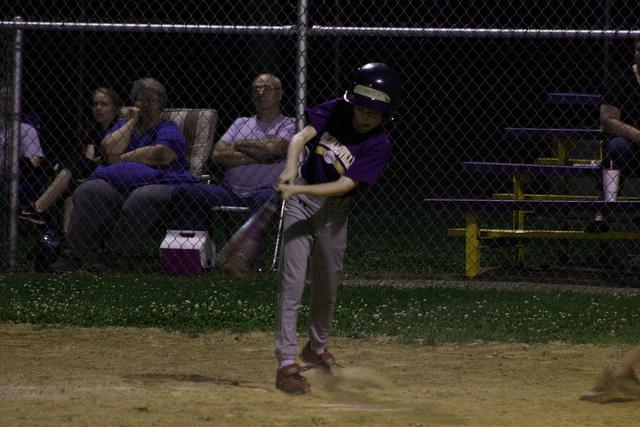How many people are on the playing field?
Quick response, please. 1. What is that sitting on the bleachers?
Short answer required. Cup. Is there a large audience?
Be succinct. No. How many bats do you see?
Short answer required. 1. Are the people behind the fence playing the game?
Be succinct. No. What is the guy doing?
Short answer required. Batting. What color are the uniforms?
Short answer required. Blue and gray. In what direction is the player reaching?
Quick response, please. Right. What sport is this?
Short answer required. Baseball. Is this part of an actual baseball game?
Be succinct. Yes. What type of ball is this?
Write a very short answer. Baseball. What kind of shirt is the kids wearing?
Write a very short answer. Jersey. Did he hit the ball?
Give a very brief answer. No. Do you see a trash can?
Concise answer only. No. 